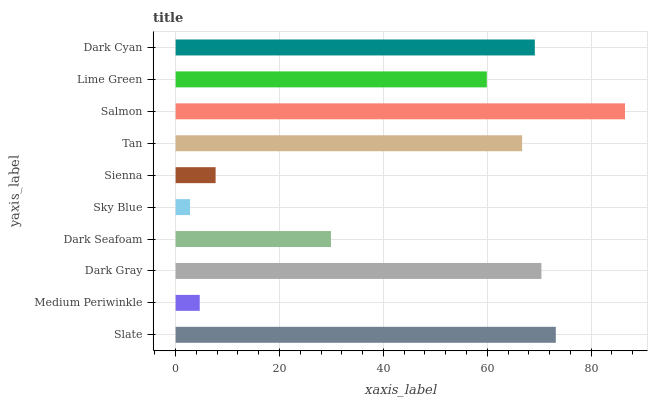Is Sky Blue the minimum?
Answer yes or no. Yes. Is Salmon the maximum?
Answer yes or no. Yes. Is Medium Periwinkle the minimum?
Answer yes or no. No. Is Medium Periwinkle the maximum?
Answer yes or no. No. Is Slate greater than Medium Periwinkle?
Answer yes or no. Yes. Is Medium Periwinkle less than Slate?
Answer yes or no. Yes. Is Medium Periwinkle greater than Slate?
Answer yes or no. No. Is Slate less than Medium Periwinkle?
Answer yes or no. No. Is Tan the high median?
Answer yes or no. Yes. Is Lime Green the low median?
Answer yes or no. Yes. Is Dark Cyan the high median?
Answer yes or no. No. Is Salmon the low median?
Answer yes or no. No. 